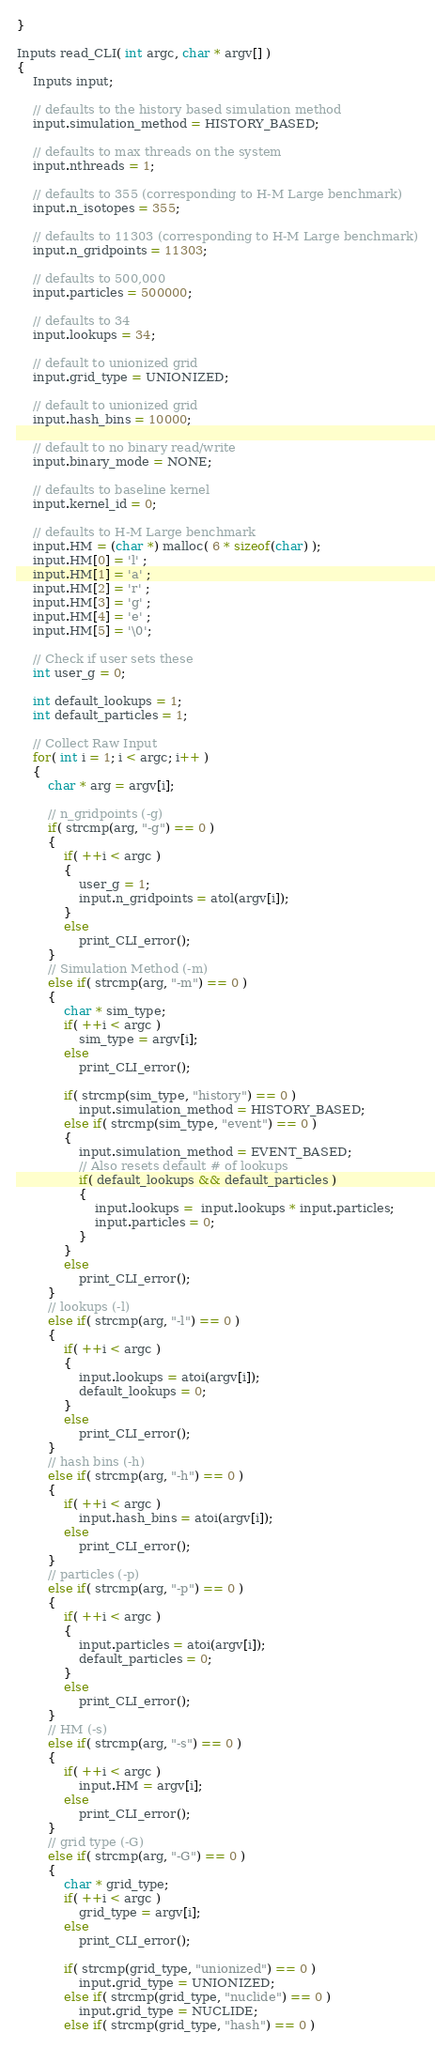<code> <loc_0><loc_0><loc_500><loc_500><_Cuda_>}

Inputs read_CLI( int argc, char * argv[] )
{
	Inputs input;

	// defaults to the history based simulation method
	input.simulation_method = HISTORY_BASED;
	
	// defaults to max threads on the system	
	input.nthreads = 1;
	
	// defaults to 355 (corresponding to H-M Large benchmark)
	input.n_isotopes = 355;
	
	// defaults to 11303 (corresponding to H-M Large benchmark)
	input.n_gridpoints = 11303;

	// defaults to 500,000
	input.particles = 500000;
	
	// defaults to 34
	input.lookups = 34;
	
	// default to unionized grid
	input.grid_type = UNIONIZED;

	// default to unionized grid
	input.hash_bins = 10000;

	// default to no binary read/write
	input.binary_mode = NONE;
	
	// defaults to baseline kernel
	input.kernel_id = 0;
	
	// defaults to H-M Large benchmark
	input.HM = (char *) malloc( 6 * sizeof(char) );
	input.HM[0] = 'l' ; 
	input.HM[1] = 'a' ; 
	input.HM[2] = 'r' ; 
	input.HM[3] = 'g' ; 
	input.HM[4] = 'e' ; 
	input.HM[5] = '\0';
	
	// Check if user sets these
	int user_g = 0;

	int default_lookups = 1;
	int default_particles = 1;
	
	// Collect Raw Input
	for( int i = 1; i < argc; i++ )
	{
		char * arg = argv[i];

		// n_gridpoints (-g)
		if( strcmp(arg, "-g") == 0 )
		{	
			if( ++i < argc )
			{
				user_g = 1;
				input.n_gridpoints = atol(argv[i]);
			}
			else
				print_CLI_error();
		}
		// Simulation Method (-m)
		else if( strcmp(arg, "-m") == 0 )
		{
			char * sim_type;
			if( ++i < argc )
				sim_type = argv[i];
			else
				print_CLI_error();

			if( strcmp(sim_type, "history") == 0 )
				input.simulation_method = HISTORY_BASED;
			else if( strcmp(sim_type, "event") == 0 )
			{
				input.simulation_method = EVENT_BASED;
				// Also resets default # of lookups
				if( default_lookups && default_particles )
				{
					input.lookups =  input.lookups * input.particles;
					input.particles = 0;
				}
			}
			else
				print_CLI_error();
		}
		// lookups (-l)
		else if( strcmp(arg, "-l") == 0 )
		{
			if( ++i < argc )
			{
				input.lookups = atoi(argv[i]);
				default_lookups = 0;
			}
			else
				print_CLI_error();
		}
		// hash bins (-h)
		else if( strcmp(arg, "-h") == 0 )
		{
			if( ++i < argc )
				input.hash_bins = atoi(argv[i]);
			else
				print_CLI_error();
		}
		// particles (-p)
		else if( strcmp(arg, "-p") == 0 )
		{
			if( ++i < argc )
			{
				input.particles = atoi(argv[i]);
				default_particles = 0;
			}
			else
				print_CLI_error();
		}
		// HM (-s)
		else if( strcmp(arg, "-s") == 0 )
		{	
			if( ++i < argc )
				input.HM = argv[i];
			else
				print_CLI_error();
		}
		// grid type (-G)
		else if( strcmp(arg, "-G") == 0 )
		{
			char * grid_type;
			if( ++i < argc )
				grid_type = argv[i];
			else
				print_CLI_error();

			if( strcmp(grid_type, "unionized") == 0 )
				input.grid_type = UNIONIZED;
			else if( strcmp(grid_type, "nuclide") == 0 )
				input.grid_type = NUCLIDE;
			else if( strcmp(grid_type, "hash") == 0 )</code> 